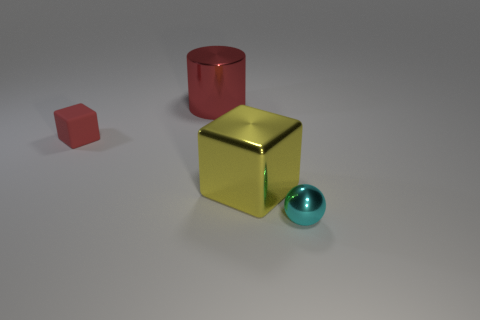Is the color of the small metallic thing the same as the big cylinder?
Make the answer very short. No. Are there more red objects than objects?
Your answer should be compact. No. What number of other objects are the same material as the large cylinder?
Offer a terse response. 2. What number of objects are either large yellow shiny blocks or large things that are left of the yellow metallic cube?
Your response must be concise. 2. Are there fewer large purple cylinders than cubes?
Your response must be concise. Yes. What is the color of the object behind the cube that is on the left side of the red thing that is on the right side of the red matte cube?
Keep it short and to the point. Red. Are the big cube and the cylinder made of the same material?
Make the answer very short. Yes. There is a large shiny block; how many large cubes are in front of it?
Give a very brief answer. 0. There is another matte object that is the same shape as the yellow object; what is its size?
Ensure brevity in your answer.  Small. How many brown things are either large cylinders or big shiny blocks?
Your answer should be compact. 0. 